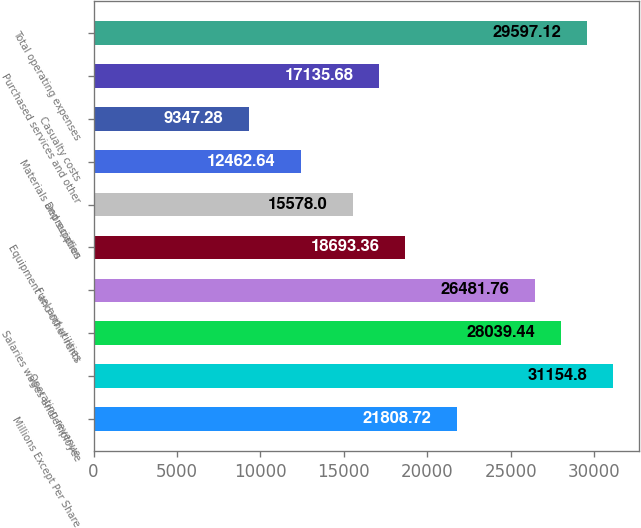Convert chart. <chart><loc_0><loc_0><loc_500><loc_500><bar_chart><fcel>Millions Except Per Share<fcel>Operating revenue<fcel>Salaries wages and employee<fcel>Fuel and utilities<fcel>Equipment and other rents<fcel>Depreciation<fcel>Materials and supplies<fcel>Casualty costs<fcel>Purchased services and other<fcel>Total operating expenses<nl><fcel>21808.7<fcel>31154.8<fcel>28039.4<fcel>26481.8<fcel>18693.4<fcel>15578<fcel>12462.6<fcel>9347.28<fcel>17135.7<fcel>29597.1<nl></chart> 